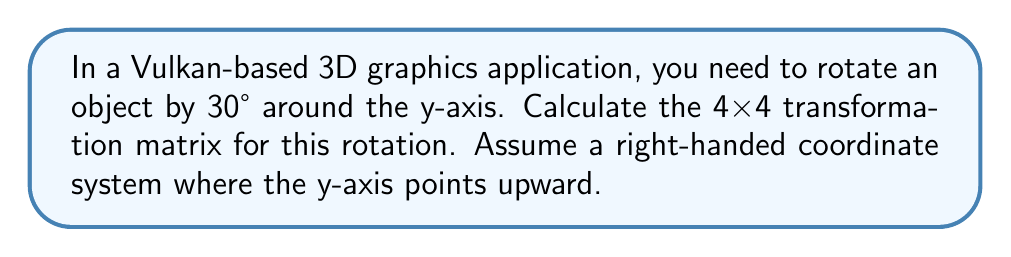Give your solution to this math problem. To calculate the transformation matrix for a 3D rotation around the y-axis, we follow these steps:

1. Recall the general form of a rotation matrix around the y-axis:

   $$R_y(\theta) = \begin{bmatrix}
   \cos\theta & 0 & \sin\theta & 0 \\
   0 & 1 & 0 & 0 \\
   -\sin\theta & 0 & \cos\theta & 0 \\
   0 & 0 & 0 & 1
   \end{bmatrix}$$

2. Convert the angle from degrees to radians:
   $\theta = 30° \times \frac{\pi}{180°} = \frac{\pi}{6}$ radians

3. Calculate $\cos\theta$ and $\sin\theta$:
   $\cos\frac{\pi}{6} = \frac{\sqrt{3}}{2}$
   $\sin\frac{\pi}{6} = \frac{1}{2}$

4. Substitute these values into the rotation matrix:

   $$R_y(30°) = \begin{bmatrix}
   \frac{\sqrt{3}}{2} & 0 & \frac{1}{2} & 0 \\
   0 & 1 & 0 & 0 \\
   -\frac{1}{2} & 0 & \frac{\sqrt{3}}{2} & 0 \\
   0 & 0 & 0 & 1
   \end{bmatrix}$$

This matrix can be directly used in Vulkan shader code or CPU-side calculations for rotating objects around the y-axis by 30°.
Answer: $$R_y(30°) = \begin{bmatrix}
\frac{\sqrt{3}}{2} & 0 & \frac{1}{2} & 0 \\
0 & 1 & 0 & 0 \\
-\frac{1}{2} & 0 & \frac{\sqrt{3}}{2} & 0 \\
0 & 0 & 0 & 1
\end{bmatrix}$$ 